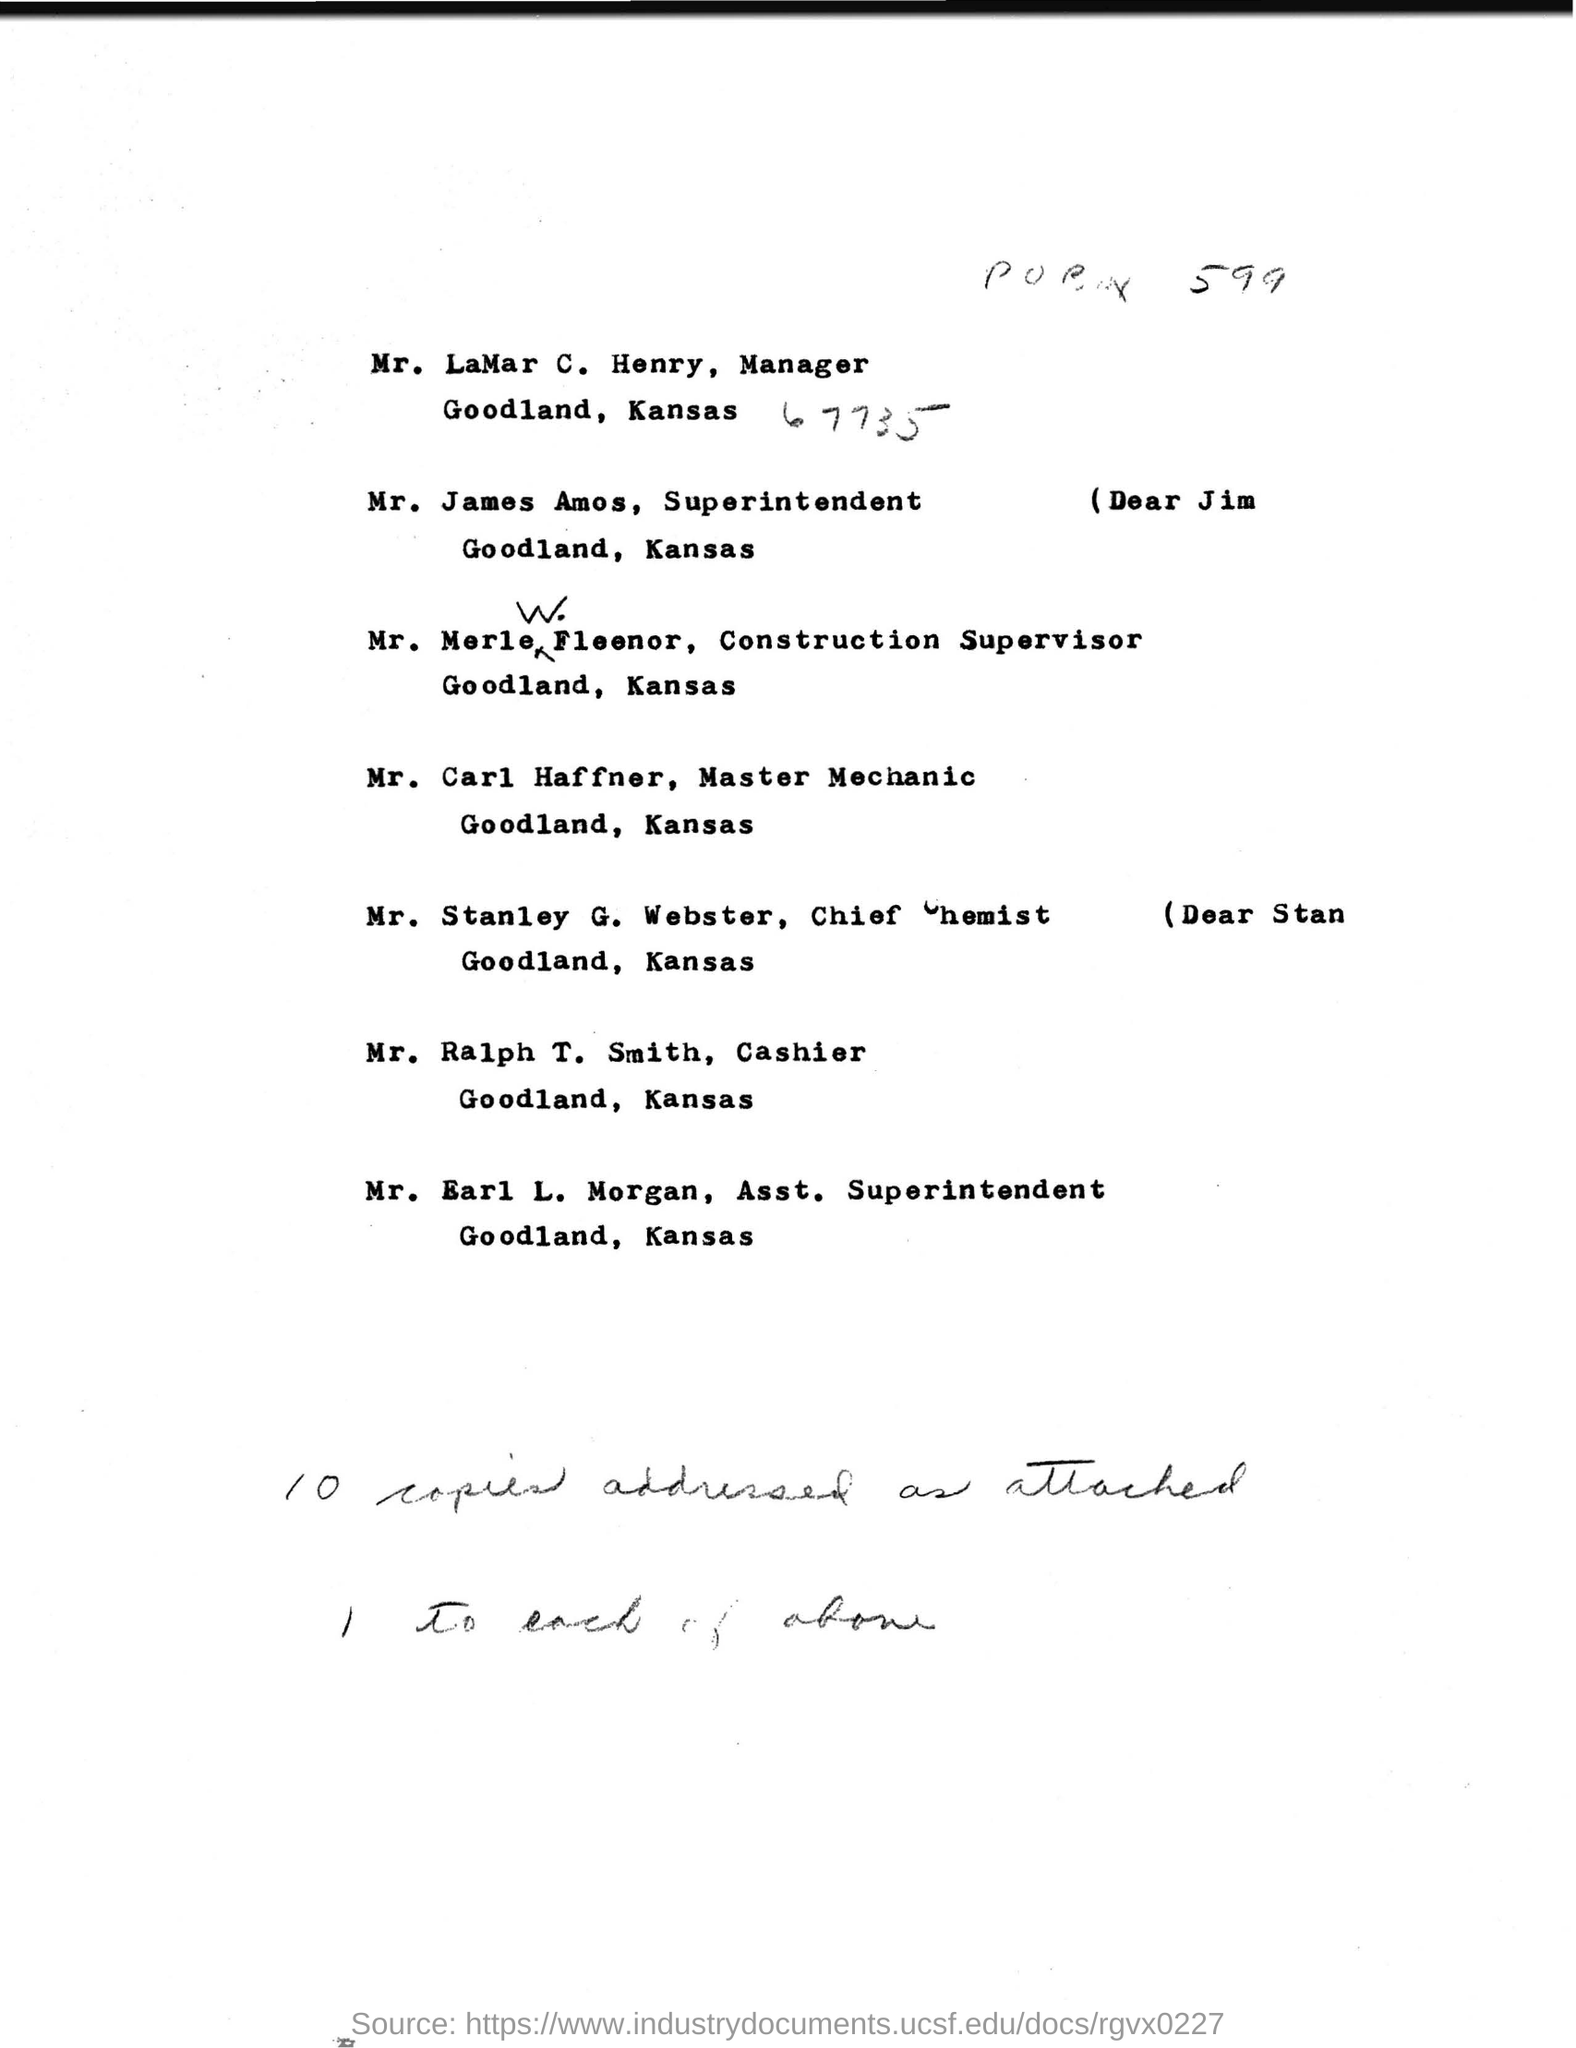What is the name of the manager mentioned ?
Your answer should be compact. Mr. LaMar C. Henry. What is the name of the superintendent mentioned ?
Ensure brevity in your answer.  Mr. James Amos. What is the name of the master mechanic mentioned ?
Your answer should be very brief. Mr. Carl Haffner. What is the name of the chief chemist mentioned ?
Make the answer very short. Mr. Stanley G. Webster. What is the name of the cashier mentioned ?
Give a very brief answer. Mr. Ralph T. Smith. What is the name of the asst. superintendent mentioned ?
Make the answer very short. Mr. Earl L. Morgan. 